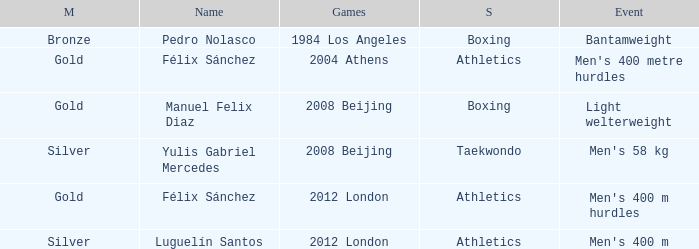Which Name had a Games of 2008 beijing, and a Medal of gold? Manuel Felix Diaz. 